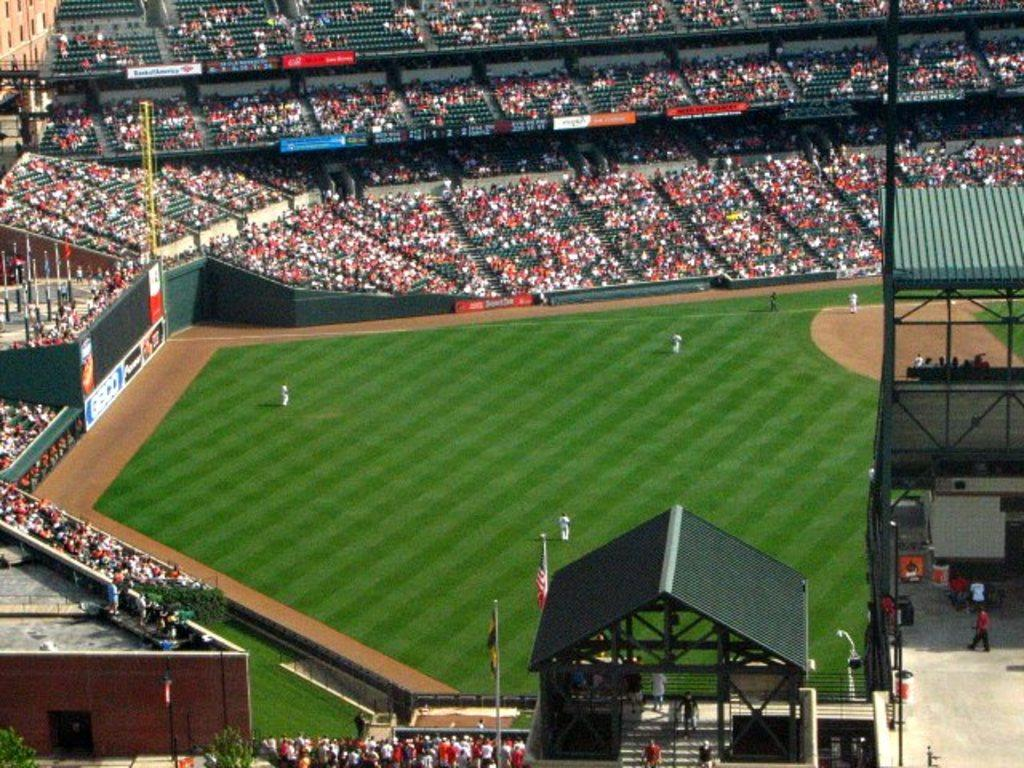What is the main subject in the middle of the image? There is a playground in the middle of the image. What can be seen in the background of the image? There is a stadium in the background of the image. Can you describe the people in the stadium? There is an audience in the stadium. Where is the cactus located in the image? There is no cactus present in the image. What unit of measurement is used to determine the distance between the playground and the stadium? The facts provided do not mention any specific unit of measurement, so it cannot be determined from the image. 